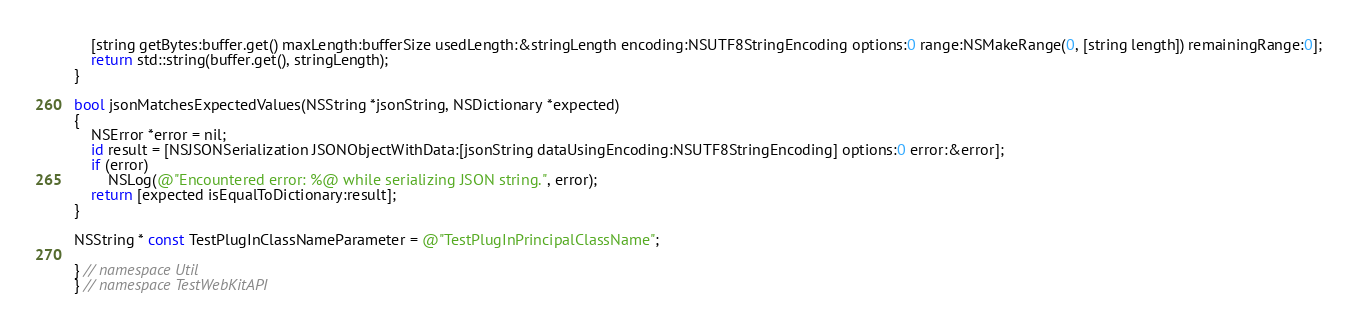Convert code to text. <code><loc_0><loc_0><loc_500><loc_500><_ObjectiveC_>    [string getBytes:buffer.get() maxLength:bufferSize usedLength:&stringLength encoding:NSUTF8StringEncoding options:0 range:NSMakeRange(0, [string length]) remainingRange:0];
    return std::string(buffer.get(), stringLength);
}

bool jsonMatchesExpectedValues(NSString *jsonString, NSDictionary *expected)
{
    NSError *error = nil;
    id result = [NSJSONSerialization JSONObjectWithData:[jsonString dataUsingEncoding:NSUTF8StringEncoding] options:0 error:&error];
    if (error)
        NSLog(@"Encountered error: %@ while serializing JSON string.", error);
    return [expected isEqualToDictionary:result];
}

NSString * const TestPlugInClassNameParameter = @"TestPlugInPrincipalClassName";

} // namespace Util
} // namespace TestWebKitAPI
</code> 